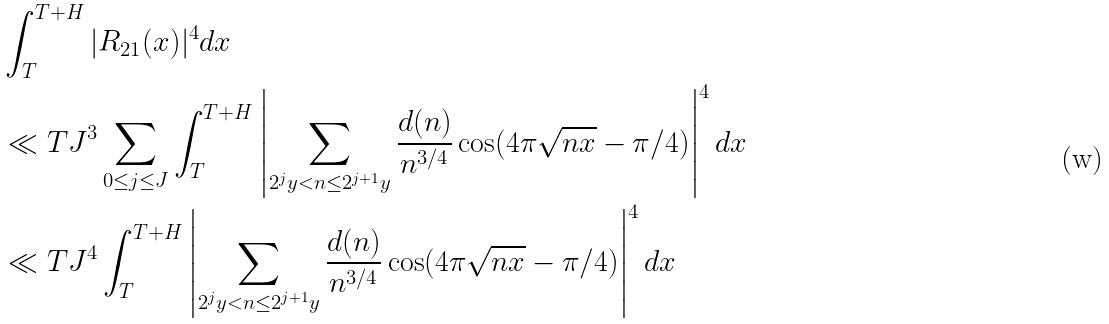Convert formula to latex. <formula><loc_0><loc_0><loc_500><loc_500>& \int _ { T } ^ { T + H } | R _ { 2 1 } ( x ) | ^ { 4 } d x \\ & \ll T J ^ { 3 } \sum _ { 0 \leq j \leq J } \int _ { T } ^ { T + H } \left | \sum _ { 2 ^ { j } y < n \leq 2 ^ { j + 1 } y } \frac { d ( n ) } { n ^ { 3 / 4 } } \cos ( 4 \pi \sqrt { n x } - \pi / 4 ) \right | ^ { 4 } d x \\ & \ll T J ^ { 4 } \int _ { T } ^ { T + H } \left | \sum _ { 2 ^ { j } y < n \leq 2 ^ { j + 1 } y } \frac { d ( n ) } { n ^ { 3 / 4 } } \cos ( 4 \pi \sqrt { n x } - \pi / 4 ) \right | ^ { 4 } d x</formula> 